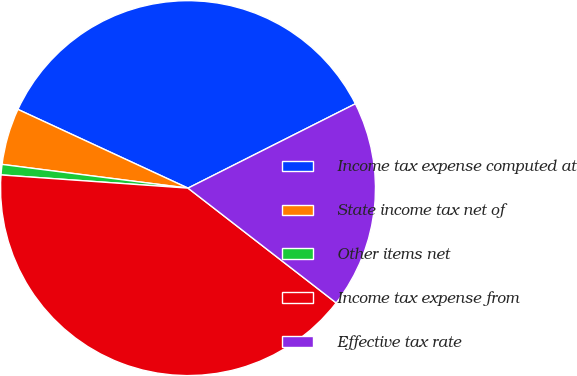<chart> <loc_0><loc_0><loc_500><loc_500><pie_chart><fcel>Income tax expense computed at<fcel>State income tax net of<fcel>Other items net<fcel>Income tax expense from<fcel>Effective tax rate<nl><fcel>35.67%<fcel>4.88%<fcel>0.9%<fcel>40.63%<fcel>17.92%<nl></chart> 